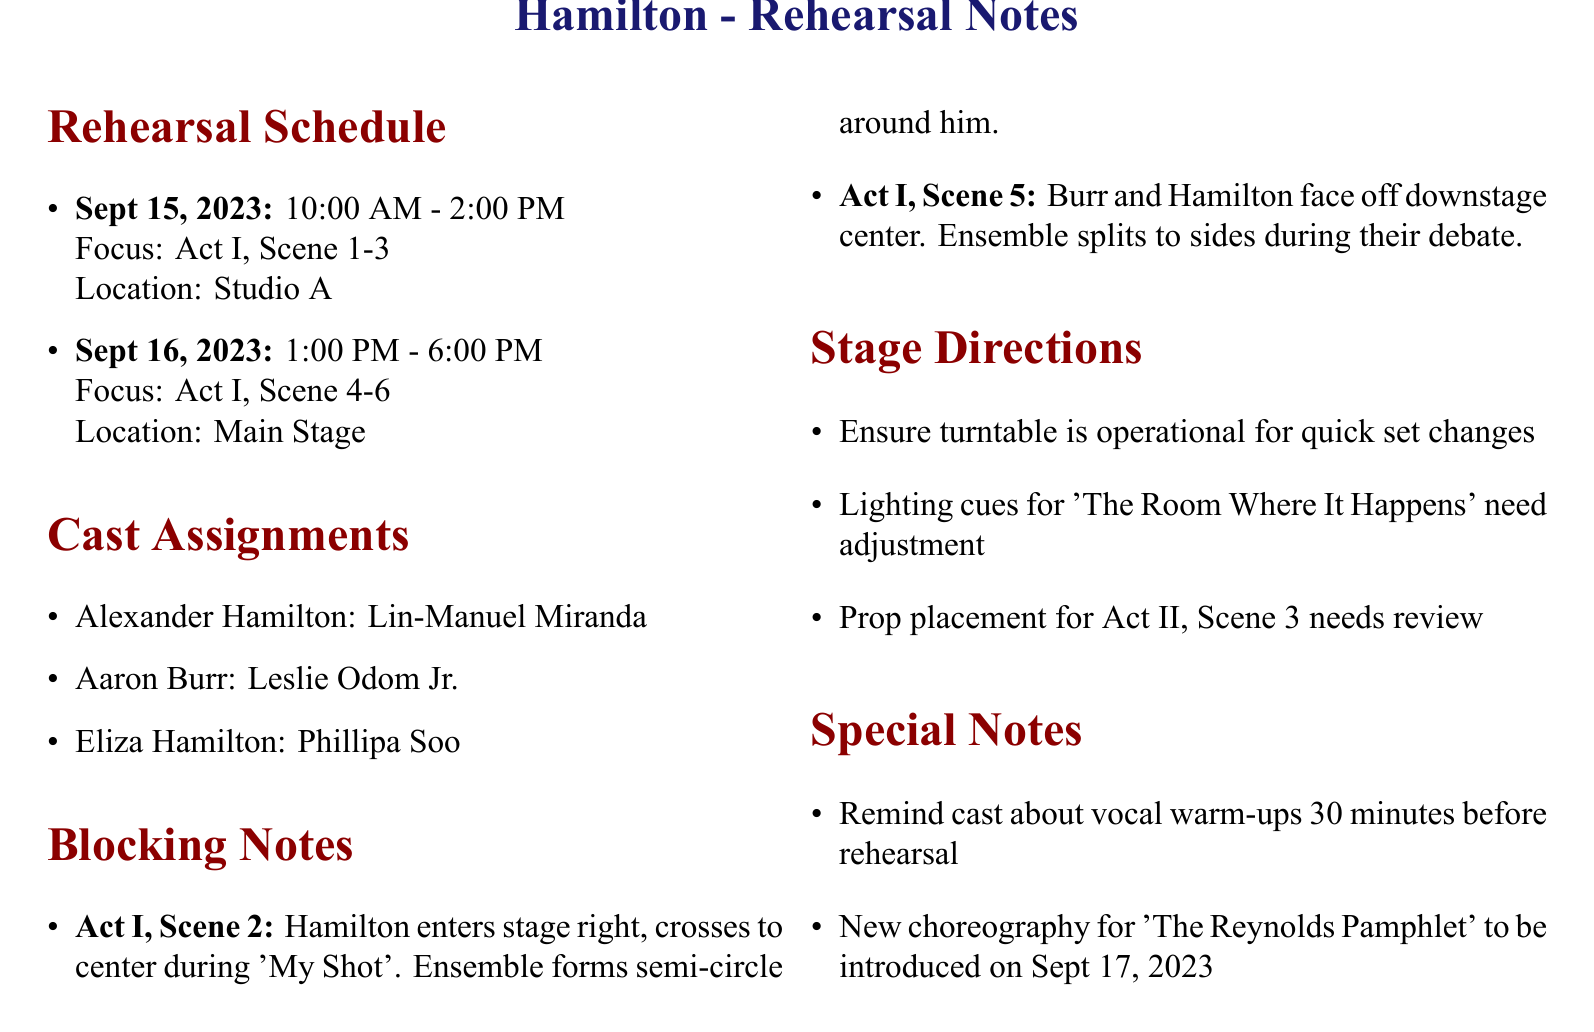What is the name of the production? The document states the title of the production at the beginning, which is "Hamilton."
Answer: Hamilton When is the rehearsal for Act I, Scene 4-6 scheduled? The rehearsal schedule includes specific dates and focuses, with Act I, Scene 4-6 scheduled on September 16, 2023.
Answer: Sept 16, 2023 Who plays the role of Eliza Hamilton? The cast assignments detail the actors for each role, and Eliza Hamilton is played by Phillipa Soo.
Answer: Phillipa Soo What are the blocking notes for Act I, Scene 5? The document provides specific directions for each blocking note, indicating that in Act I, Scene 5, Burr and Hamilton face off downstage center.
Answer: Burr and Hamilton face off downstage center What special note is mentioned regarding vocal warm-ups? The special notes section highlights a reminder about vocal warm-ups for the cast 30 minutes before rehearsal.
Answer: 30 minutes before rehearsal What is the focus of the rehearsal on September 15, 2023? The rehearsal schedule lists the focus for September 15, 2023, as Act I, Scene 1-3.
Answer: Act I, Scene 1-3 How many cast members are assigned in the document? The cast assignments section contains a list of roles, which includes three cast members assigned in the production.
Answer: 3 